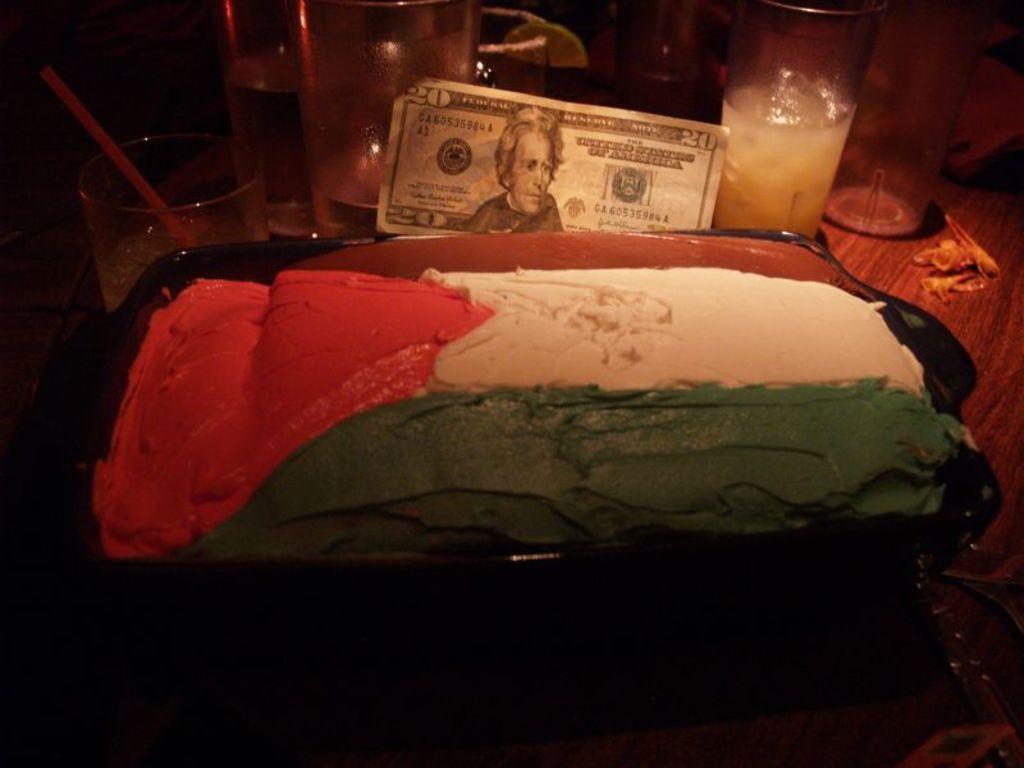Describe this image in one or two sentences. In this picture I can see food item in the tray. I can see the glasses. I can see the table. 